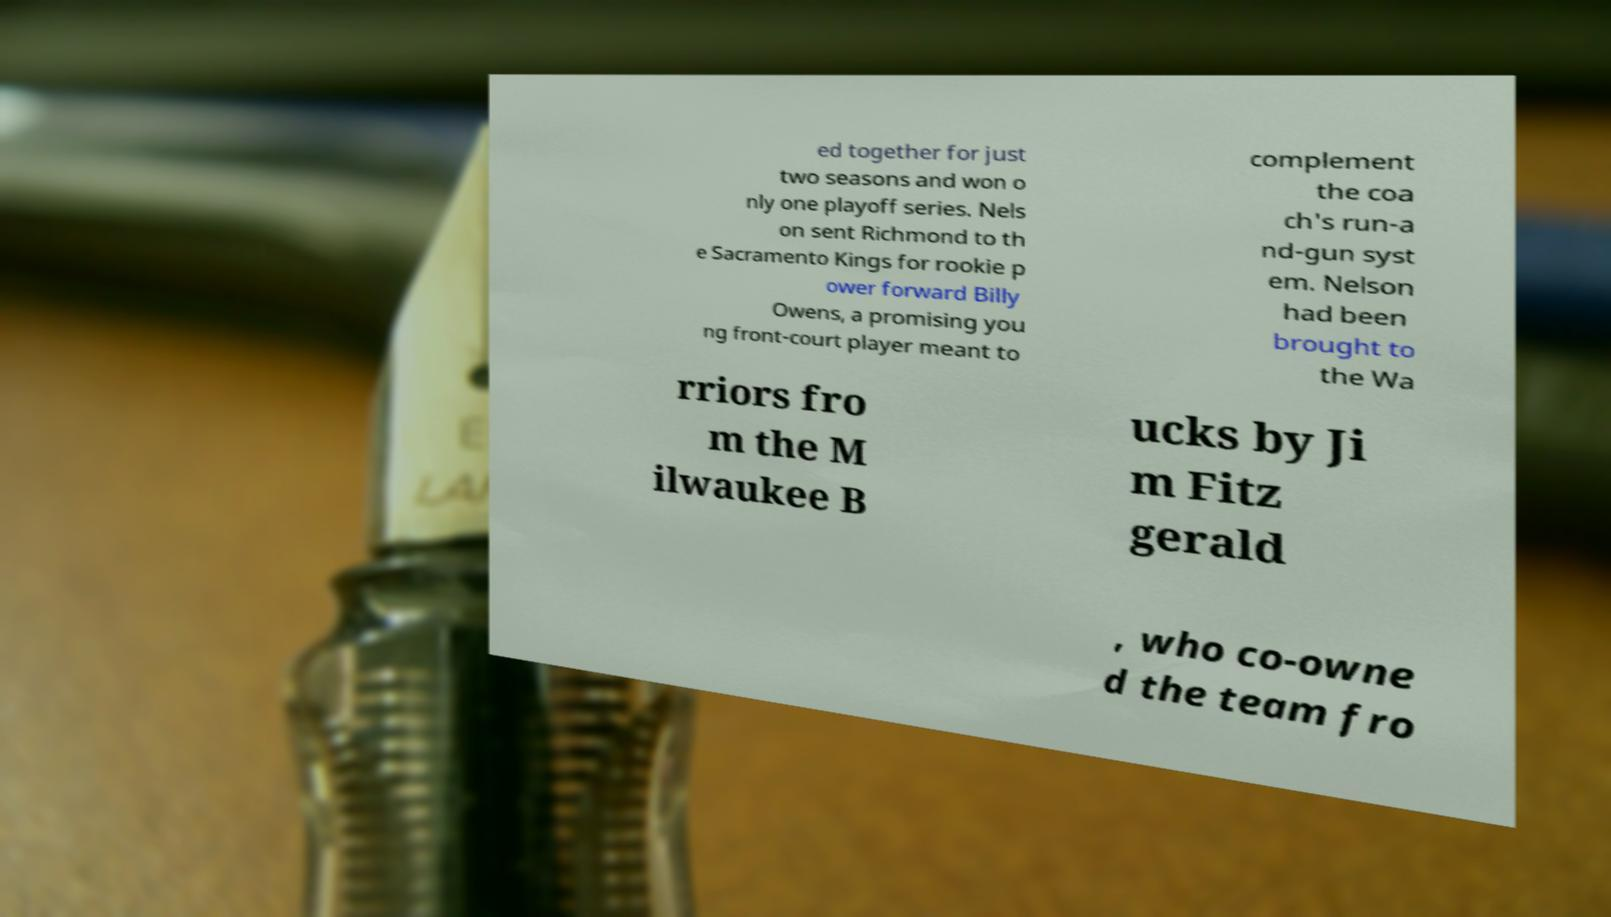Can you accurately transcribe the text from the provided image for me? ed together for just two seasons and won o nly one playoff series. Nels on sent Richmond to th e Sacramento Kings for rookie p ower forward Billy Owens, a promising you ng front-court player meant to complement the coa ch's run-a nd-gun syst em. Nelson had been brought to the Wa rriors fro m the M ilwaukee B ucks by Ji m Fitz gerald , who co-owne d the team fro 